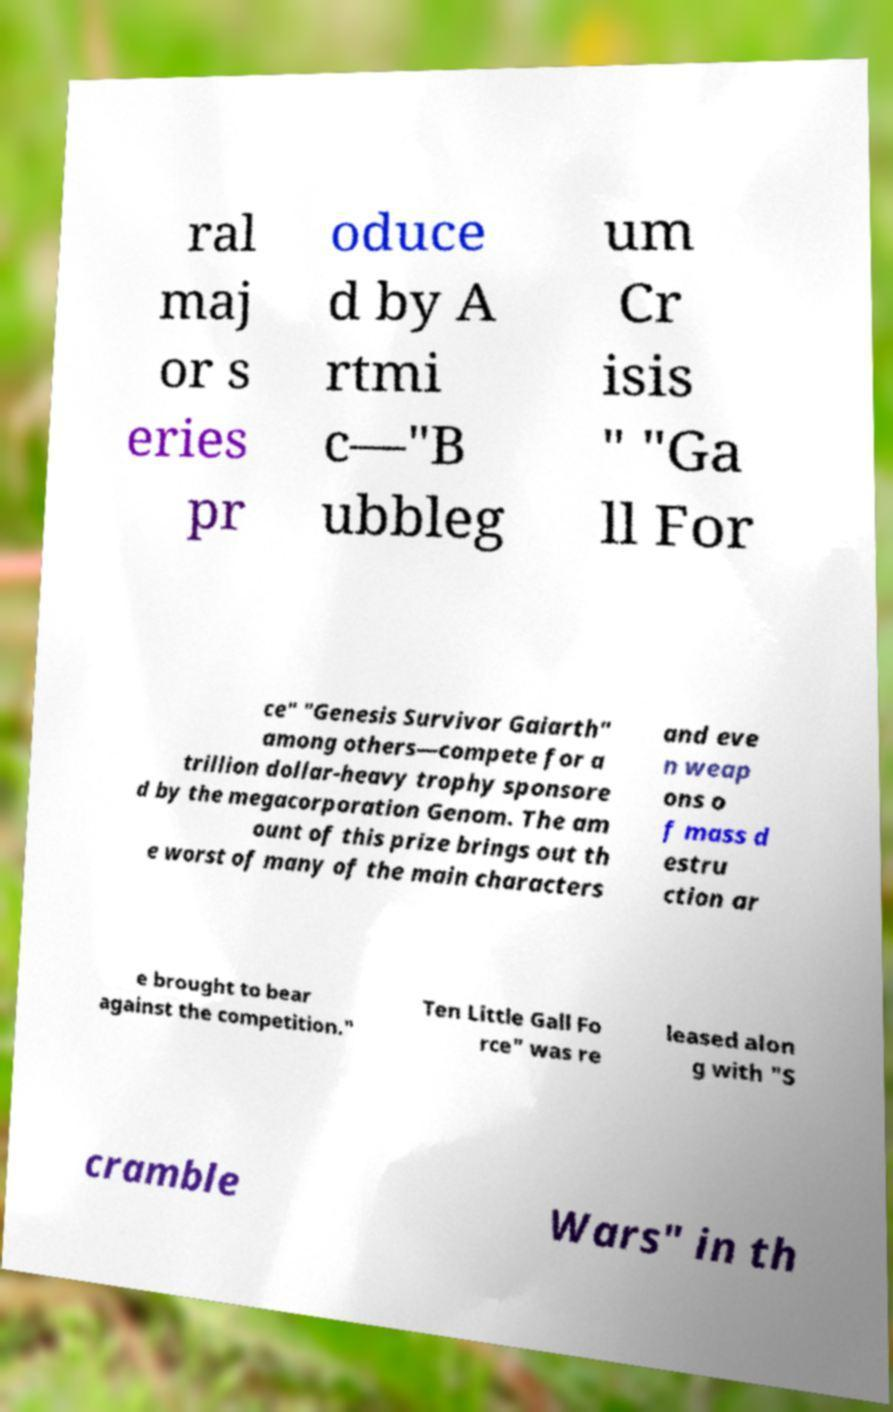Please identify and transcribe the text found in this image. ral maj or s eries pr oduce d by A rtmi c—"B ubbleg um Cr isis " "Ga ll For ce" "Genesis Survivor Gaiarth" among others—compete for a trillion dollar-heavy trophy sponsore d by the megacorporation Genom. The am ount of this prize brings out th e worst of many of the main characters and eve n weap ons o f mass d estru ction ar e brought to bear against the competition." Ten Little Gall Fo rce" was re leased alon g with "S cramble Wars" in th 